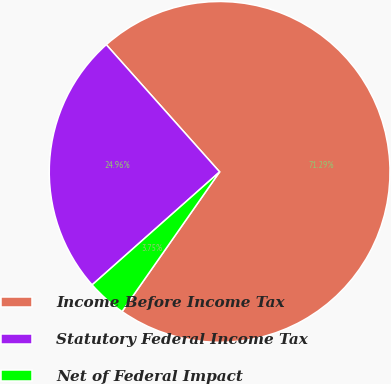Convert chart to OTSL. <chart><loc_0><loc_0><loc_500><loc_500><pie_chart><fcel>Income Before Income Tax<fcel>Statutory Federal Income Tax<fcel>Net of Federal Impact<nl><fcel>71.29%<fcel>24.96%<fcel>3.75%<nl></chart> 